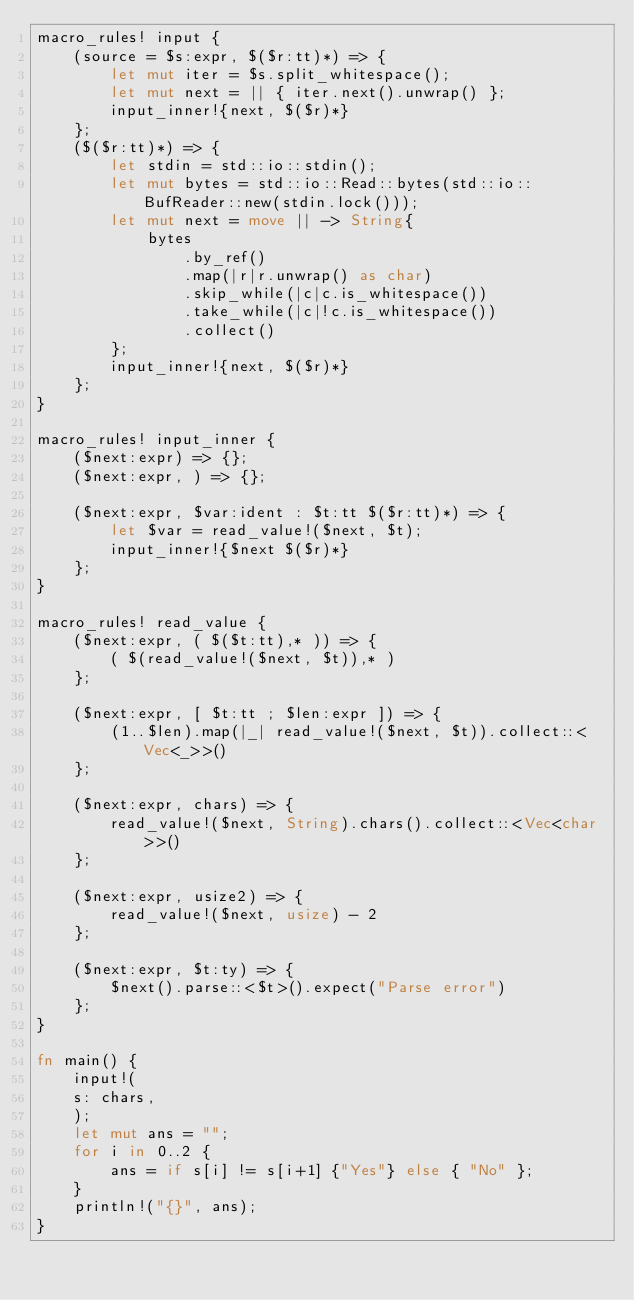Convert code to text. <code><loc_0><loc_0><loc_500><loc_500><_Rust_>macro_rules! input {
    (source = $s:expr, $($r:tt)*) => {
        let mut iter = $s.split_whitespace();
        let mut next = || { iter.next().unwrap() };
        input_inner!{next, $($r)*}
    };
    ($($r:tt)*) => {
        let stdin = std::io::stdin();
        let mut bytes = std::io::Read::bytes(std::io::BufReader::new(stdin.lock()));
        let mut next = move || -> String{
            bytes
                .by_ref()
                .map(|r|r.unwrap() as char)
                .skip_while(|c|c.is_whitespace())
                .take_while(|c|!c.is_whitespace())
                .collect()
        };
        input_inner!{next, $($r)*}
    };
}

macro_rules! input_inner {
    ($next:expr) => {};
    ($next:expr, ) => {};

    ($next:expr, $var:ident : $t:tt $($r:tt)*) => {
        let $var = read_value!($next, $t);
        input_inner!{$next $($r)*}
    };
}

macro_rules! read_value {
    ($next:expr, ( $($t:tt),* )) => {
        ( $(read_value!($next, $t)),* )
    };

    ($next:expr, [ $t:tt ; $len:expr ]) => {
        (1..$len).map(|_| read_value!($next, $t)).collect::<Vec<_>>()
    };

    ($next:expr, chars) => {
        read_value!($next, String).chars().collect::<Vec<char>>()
    };

    ($next:expr, usize2) => {
        read_value!($next, usize) - 2
    };

    ($next:expr, $t:ty) => {
        $next().parse::<$t>().expect("Parse error")
    };
}

fn main() {
    input!(
    s: chars,
    );
    let mut ans = "";
    for i in 0..2 {
        ans = if s[i] != s[i+1] {"Yes"} else { "No" };
    }
    println!("{}", ans);
}
</code> 